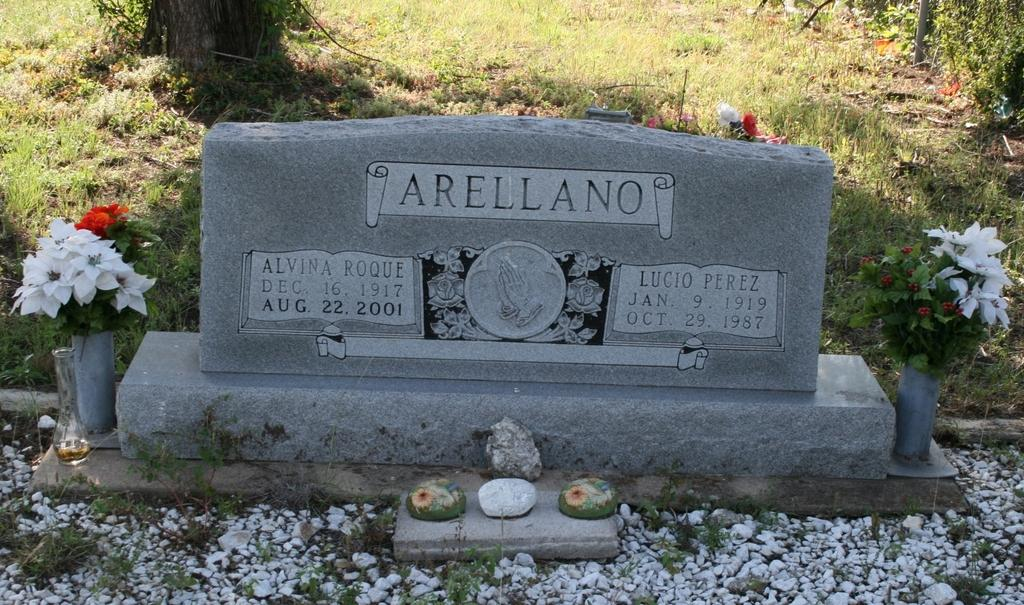What type of location is depicted in the image? There is a cemetery in the image. Are there any objects or features near the cemetery? Yes, there are flower vases on both sides of the cemetery. What can be seen in the background of the image? There is grass visible behind the cemetery. What type of prose is being recited by the women in the image? There are no women or prose present in the image; it features a cemetery and flower vases. 